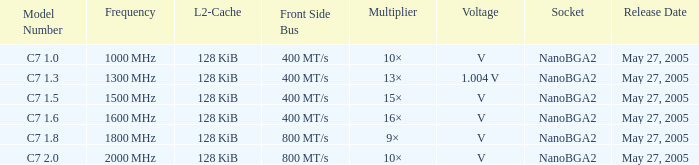What is the recurrence for model number c7 1000 MHz. 